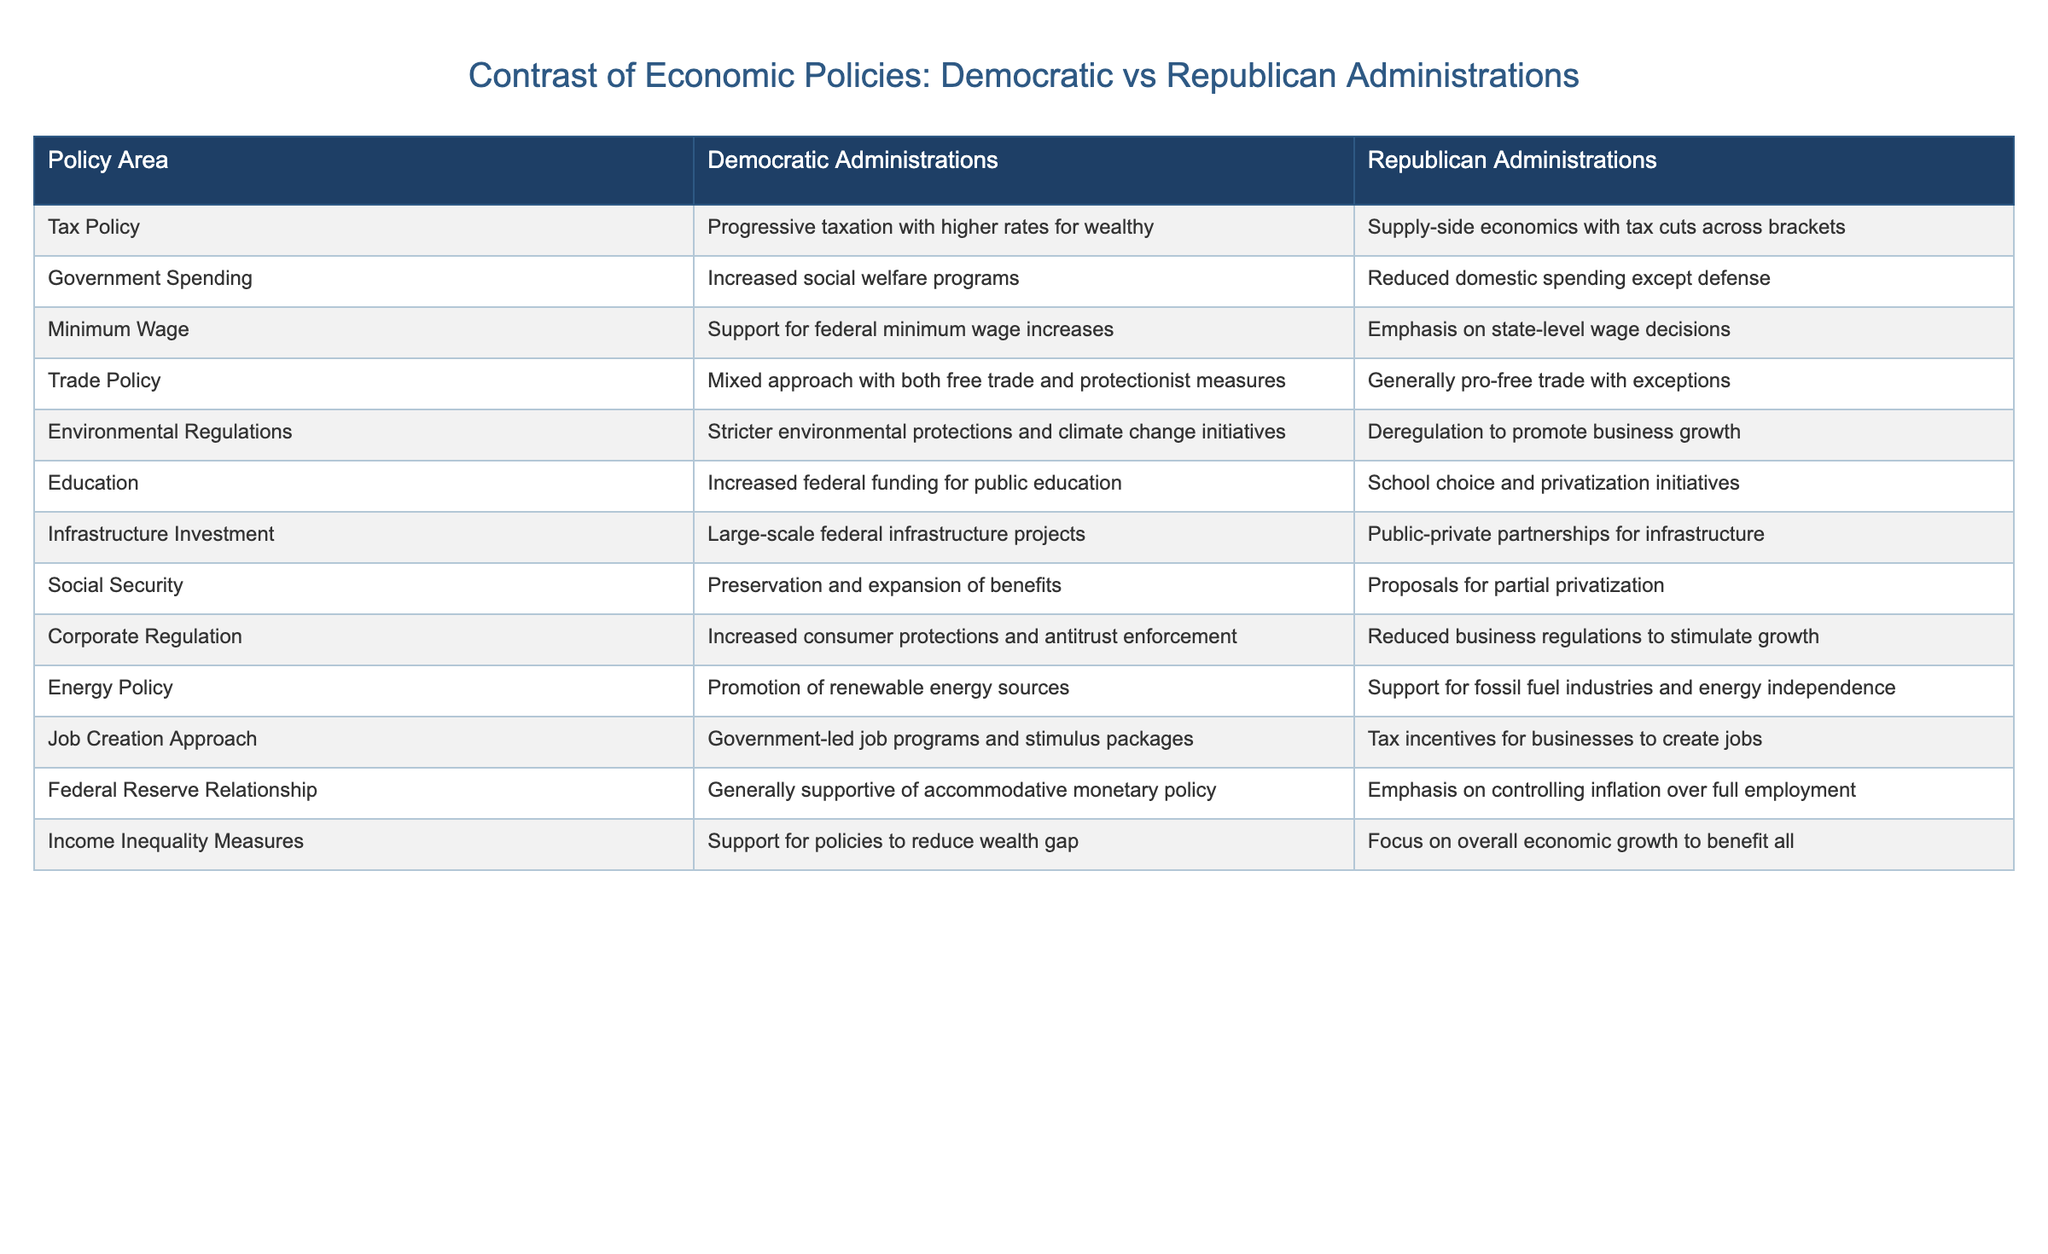What is the tax policy under Democratic administrations? According to the table, Democratic administrations support a progressive taxation system with higher rates for the wealthy.
Answer: Progressive taxation with higher rates for wealthy What do Republican administrations emphasize regarding minimum wage? The table indicates that Republican administrations focus on state-level decisions for minimum wage rather than federal increases.
Answer: Emphasis on state-level wage decisions Which party is associated with increased social welfare programs? The table shows that Democratic administrations are known for increasing social welfare programs compared to their Republican counterparts.
Answer: Democratic administrations Is the approach to education the same for both parties? An examination of the table reveals differing approaches: Democrats favor increased federal funding while Republicans advocate for school choice and privatization, thus indicating that they are not the same.
Answer: No What is the difference in job creation approaches between the two parties? The table lists that Democrats prefer government-led job programs and stimulus packages, while Republicans favor tax incentives for businesses to create jobs, thus illustrating a fundamental difference in their approaches.
Answer: Government-led vs. tax incentives Which party's policies promote renewable energy sources? Based on the table, Democratic administrations promote renewable energy sources, in contrast to Republican administrations which support fossil fuel industries.
Answer: Democratic administrations What is the overall relationship of the Federal Reserve with Democratic administrations compared to Republican administrations? The table defines that Democratic administrations are generally supportive of accommodative monetary policies, while Republican administrations emphasize controlling inflation over full employment, highlighting a significant contrast in their relationships with the Federal Reserve.
Answer: Supportive vs. control inflation Count the number of areas where Democratic administrations favor increased funding or support. By reviewing the table, we see that in areas like education, infrastructure investment, social security, and job creation approach, Democratic administrations are more favoring increased funding or support. Analyzing these areas gives a total count of four.
Answer: 4 How do the corporate regulation policies differ between the two parties? From the table, it is evident that Democratic administrations increase consumer protections and antitrust enforcement, whereas Republican administrations opt for reduced business regulations to stimulate growth. This comparison showcases the differing stances on corporate regulation.
Answer: Increased protections vs. reduced regulations Do Republican administrations support increased consumer protections? Looking at the table, it clearly shows that Republican administrations reduce business regulations to stimulate growth, which implies a lower emphasis on increased consumer protections compared to Democrats.
Answer: No 